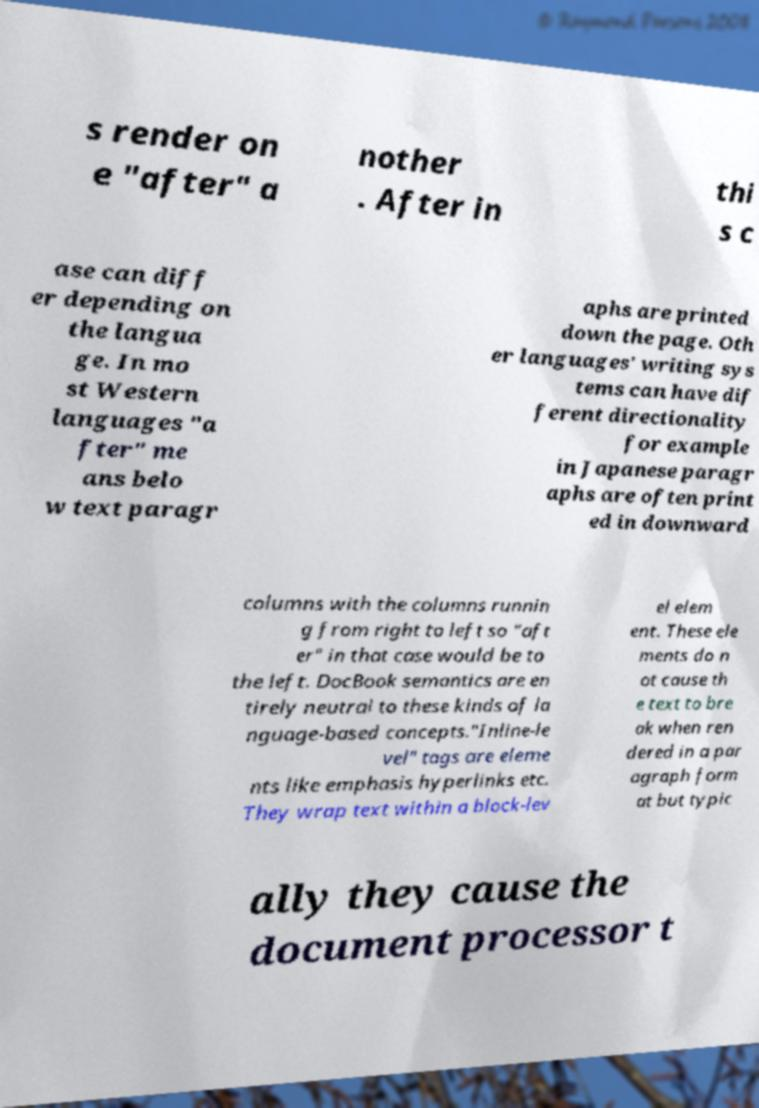There's text embedded in this image that I need extracted. Can you transcribe it verbatim? s render on e "after" a nother . After in thi s c ase can diff er depending on the langua ge. In mo st Western languages "a fter" me ans belo w text paragr aphs are printed down the page. Oth er languages' writing sys tems can have dif ferent directionality for example in Japanese paragr aphs are often print ed in downward columns with the columns runnin g from right to left so "aft er" in that case would be to the left. DocBook semantics are en tirely neutral to these kinds of la nguage-based concepts."Inline-le vel" tags are eleme nts like emphasis hyperlinks etc. They wrap text within a block-lev el elem ent. These ele ments do n ot cause th e text to bre ak when ren dered in a par agraph form at but typic ally they cause the document processor t 